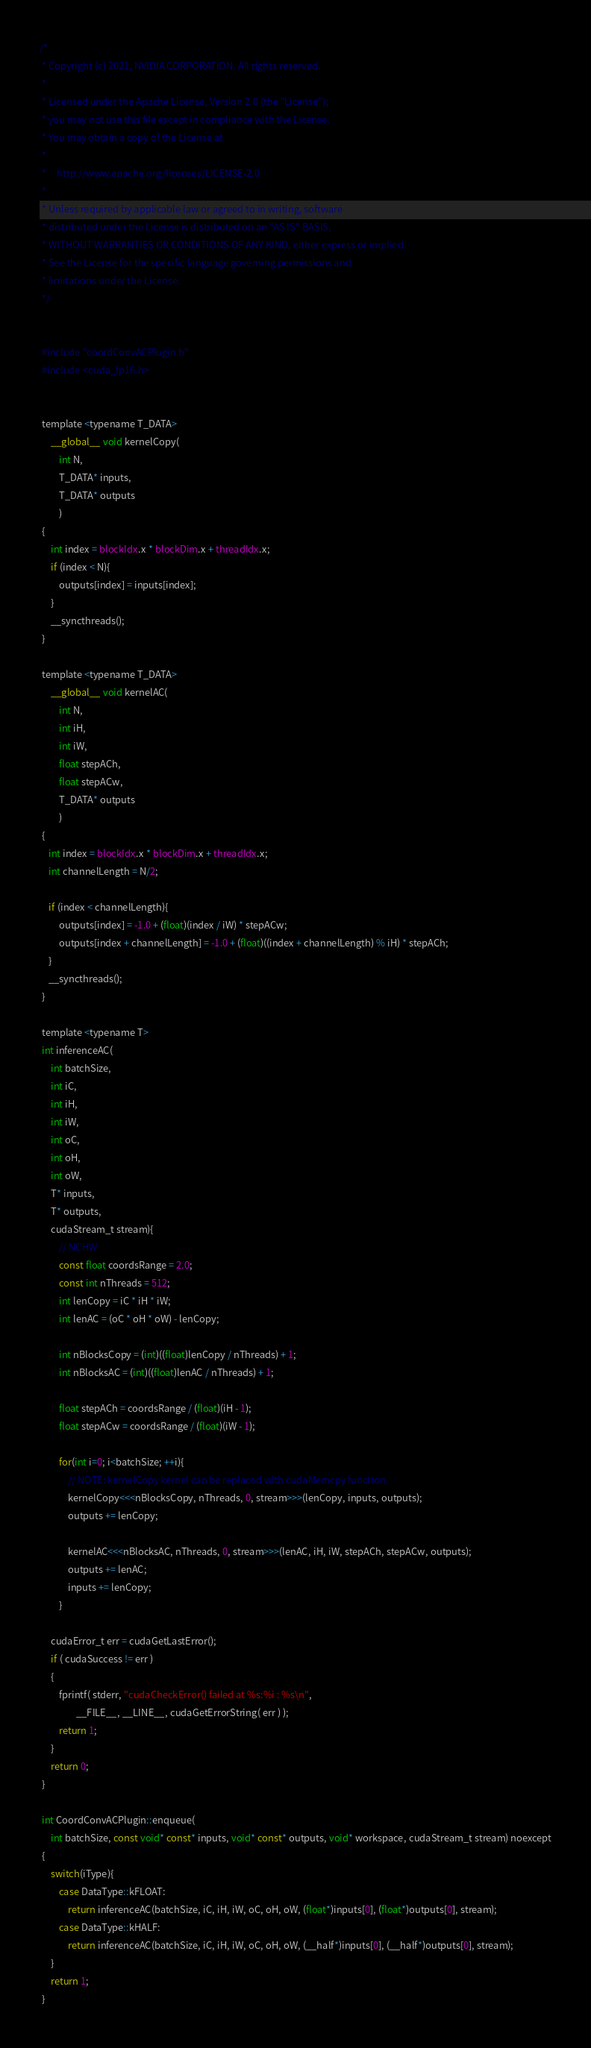Convert code to text. <code><loc_0><loc_0><loc_500><loc_500><_Cuda_>/*
 * Copyright (c) 2021, NVIDIA CORPORATION. All rights reserved.
 *
 * Licensed under the Apache License, Version 2.0 (the "License");
 * you may not use this file except in compliance with the License.
 * You may obtain a copy of the License at
 *
 *     http://www.apache.org/licenses/LICENSE-2.0
 *
 * Unless required by applicable law or agreed to in writing, software
 * distributed under the License is distributed on an "AS IS" BASIS,
 * WITHOUT WARRANTIES OR CONDITIONS OF ANY KIND, either express or implied.
 * See the License for the specific language governing permissions and
 * limitations under the License.
 */


 #include "coordConvACPlugin.h"
 #include <cuda_fp16.h>


 template <typename T_DATA>
     __global__ void kernelCopy(
         int N,
         T_DATA* inputs,
         T_DATA* outputs
         )
 {
     int index = blockIdx.x * blockDim.x + threadIdx.x;
     if (index < N){
         outputs[index] = inputs[index];
     }
     __syncthreads();
 }

 template <typename T_DATA>
     __global__ void kernelAC(
         int N,
         int iH,
         int iW,
         float stepACh,
         float stepACw,
         T_DATA* outputs
         )
 {
    int index = blockIdx.x * blockDim.x + threadIdx.x;
    int channelLength = N/2;

    if (index < channelLength){
         outputs[index] = -1.0 + (float)(index / iW) * stepACw;
         outputs[index + channelLength] = -1.0 + (float)((index + channelLength) % iH) * stepACh;
    }
    __syncthreads();
 }

 template <typename T>
 int inferenceAC(
     int batchSize,
     int iC,
     int iH,
     int iW,
     int oC,
     int oH,
     int oW,
     T* inputs,
     T* outputs,
     cudaStream_t stream){
         // NCHW
         const float coordsRange = 2.0;
         const int nThreads = 512;
         int lenCopy = iC * iH * iW;
         int lenAC = (oC * oH * oW) - lenCopy;

         int nBlocksCopy = (int)((float)lenCopy / nThreads) + 1;
         int nBlocksAC = (int)((float)lenAC / nThreads) + 1;

         float stepACh = coordsRange / (float)(iH - 1);
         float stepACw = coordsRange / (float)(iW - 1);

         for(int i=0; i<batchSize; ++i){
             // NOTE: kernelCopy kernel can be replaced with cudaMemcpy function
             kernelCopy<<<nBlocksCopy, nThreads, 0, stream>>>(lenCopy, inputs, outputs);
             outputs += lenCopy;

             kernelAC<<<nBlocksAC, nThreads, 0, stream>>>(lenAC, iH, iW, stepACh, stepACw, outputs);
             outputs += lenAC;
             inputs += lenCopy;
         }

     cudaError_t err = cudaGetLastError();
     if ( cudaSuccess != err )
     {
         fprintf( stderr, "cudaCheckError() failed at %s:%i : %s\n",
                 __FILE__, __LINE__, cudaGetErrorString( err ) );
         return 1;
     }
     return 0;
 }

 int CoordConvACPlugin::enqueue(
     int batchSize, const void* const* inputs, void* const* outputs, void* workspace, cudaStream_t stream) noexcept
 {
     switch(iType){
         case DataType::kFLOAT:
             return inferenceAC(batchSize, iC, iH, iW, oC, oH, oW, (float*)inputs[0], (float*)outputs[0], stream);
         case DataType::kHALF:
             return inferenceAC(batchSize, iC, iH, iW, oC, oH, oW, (__half*)inputs[0], (__half*)outputs[0], stream);
     }
     return 1;
 }
</code> 